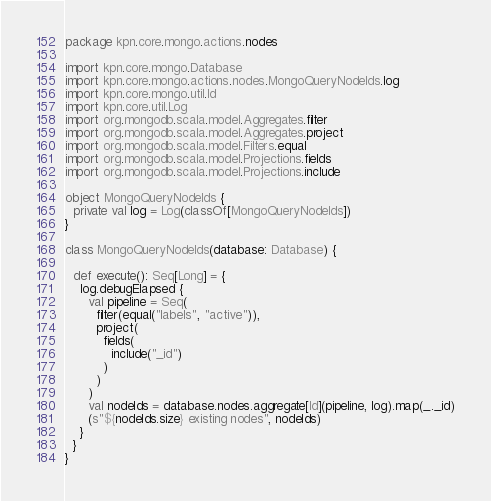Convert code to text. <code><loc_0><loc_0><loc_500><loc_500><_Scala_>package kpn.core.mongo.actions.nodes

import kpn.core.mongo.Database
import kpn.core.mongo.actions.nodes.MongoQueryNodeIds.log
import kpn.core.mongo.util.Id
import kpn.core.util.Log
import org.mongodb.scala.model.Aggregates.filter
import org.mongodb.scala.model.Aggregates.project
import org.mongodb.scala.model.Filters.equal
import org.mongodb.scala.model.Projections.fields
import org.mongodb.scala.model.Projections.include

object MongoQueryNodeIds {
  private val log = Log(classOf[MongoQueryNodeIds])
}

class MongoQueryNodeIds(database: Database) {

  def execute(): Seq[Long] = {
    log.debugElapsed {
      val pipeline = Seq(
        filter(equal("labels", "active")),
        project(
          fields(
            include("_id")
          )
        )
      )
      val nodeIds = database.nodes.aggregate[Id](pipeline, log).map(_._id)
      (s"${nodeIds.size} existing nodes", nodeIds)
    }
  }
}
</code> 